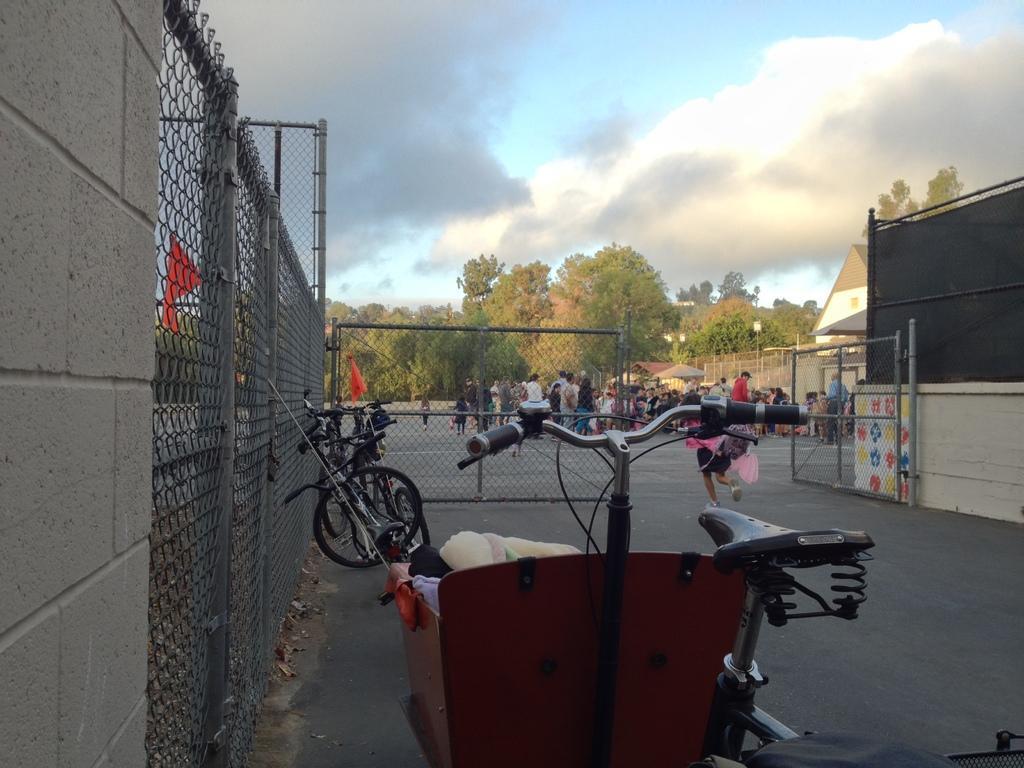Describe this image in one or two sentences. Sky is cloudy. Here we can see mesh, gate, bicycles, house, shed, people and trees. These are flags. In this basket there are things. 